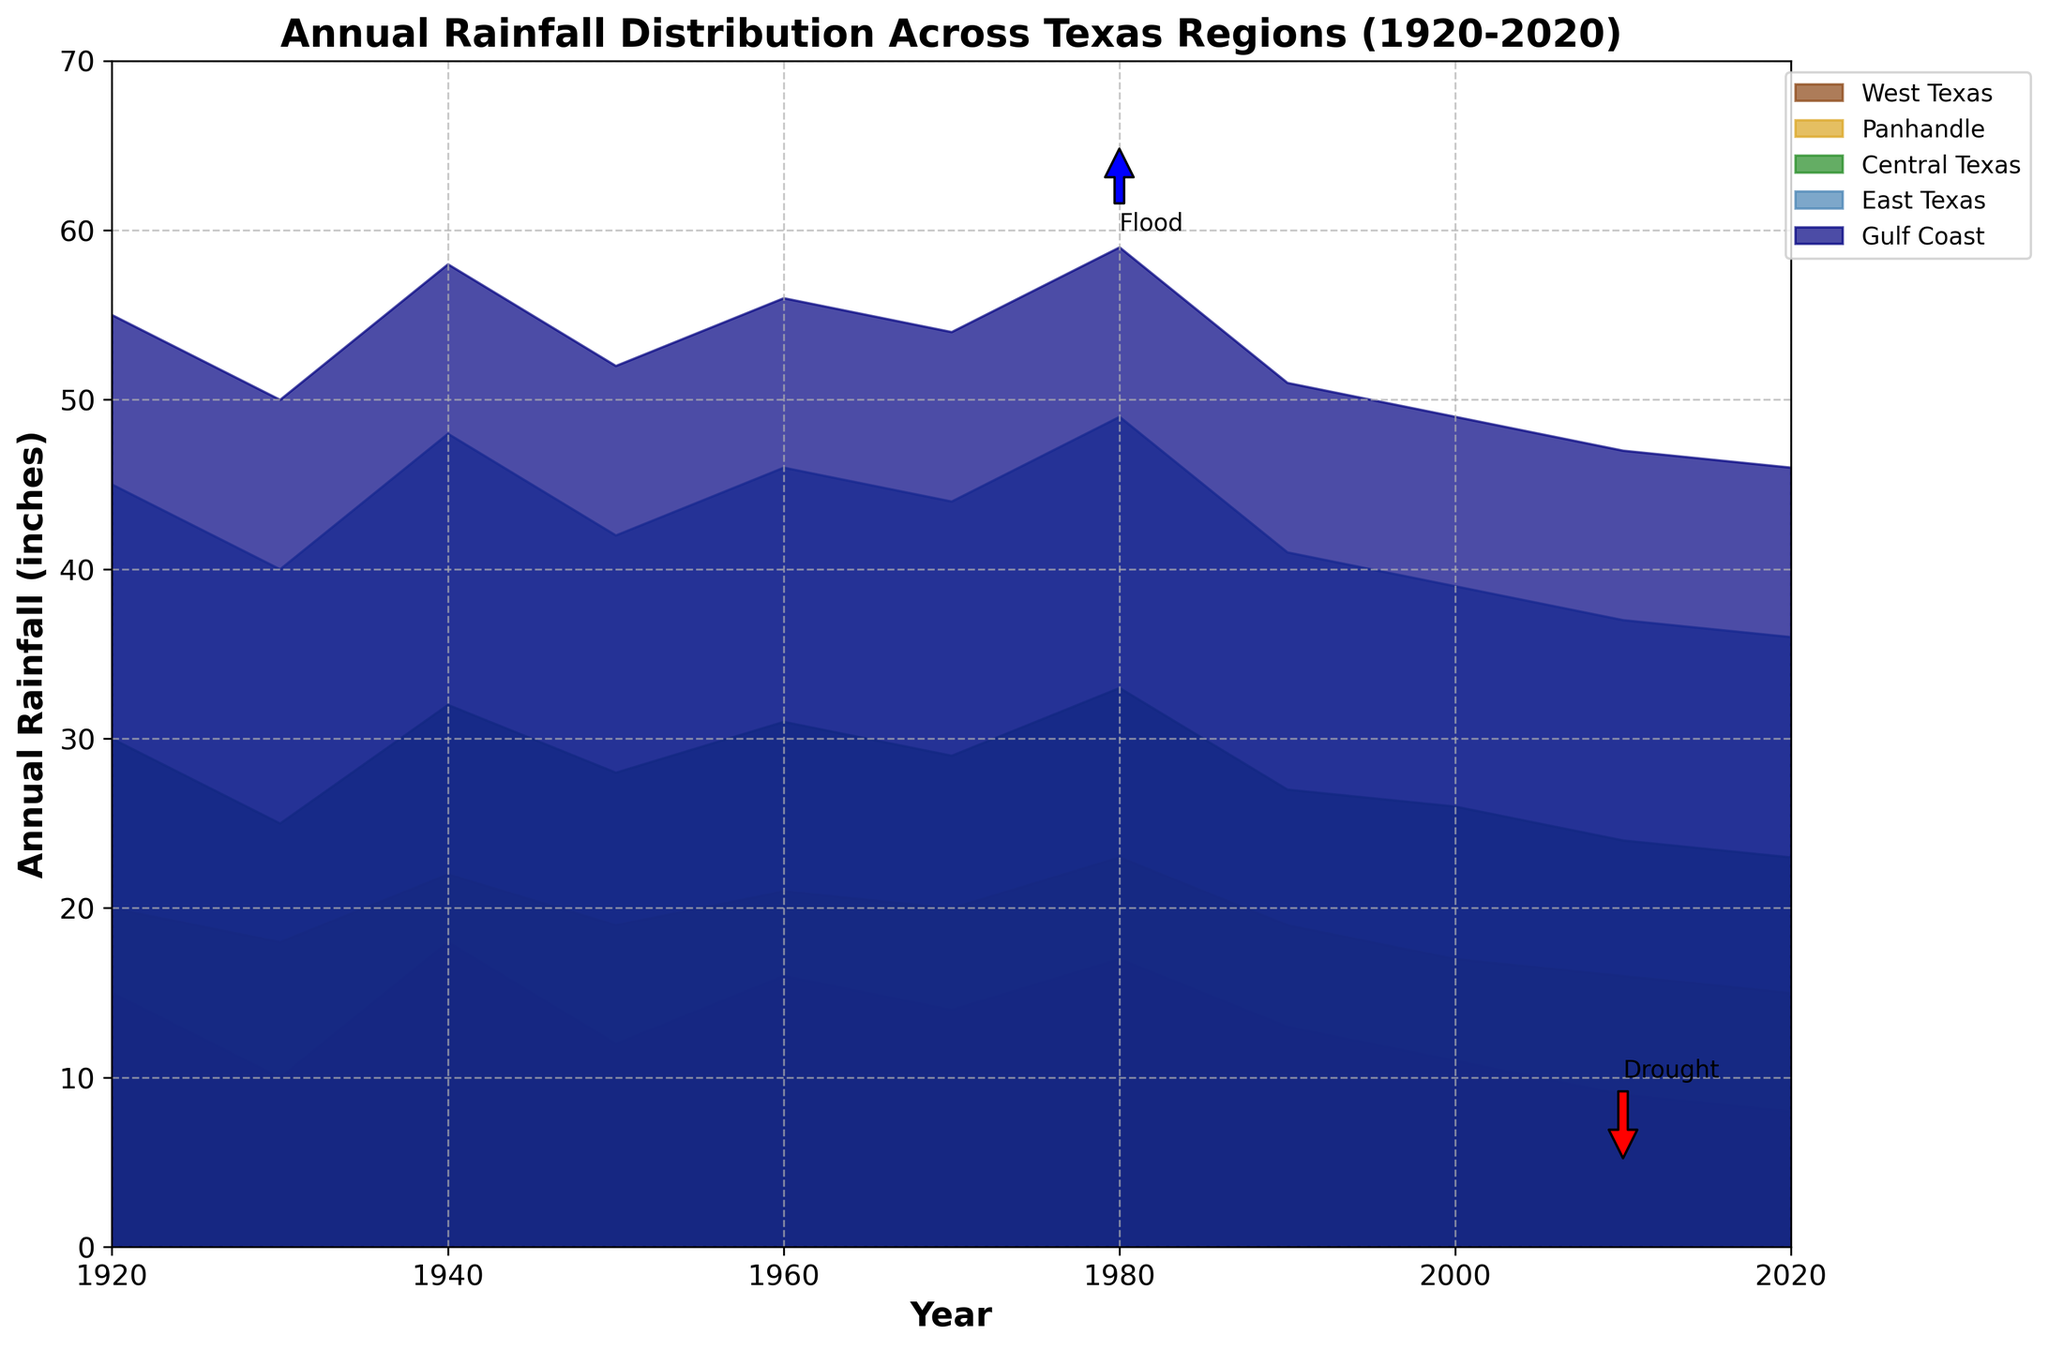What is the title of the chart? The title is typically found at the top of the chart and provides an overview of what the chart represents. It reads "Annual Rainfall Distribution Across Texas Regions (1920-2020)".
Answer: Annual Rainfall Distribution Across Texas Regions (1920-2020) Which Texas region had the highest rainfall in 1980? To find this, look at the highest point in the colored bands in 1980. The Gulf Coast region exhibits the highest rainfall, reaching almost 60 inches.
Answer: Gulf Coast What is the range of annual rainfall for West Texas over the century? For this, observe the range of the West Texas band from 1920 to 2020. It varies roughly from 8 to 18 inches.
Answer: 8 to 18 inches Which Texas region shows a consistent decline in rainfall from 1920 to 2020? To determine this, look for a consistent downward trend in the visual representation. West Texas shows a steady decline from 15 inches in 1920 to 8 inches in 2020.
Answer: West Texas Between the years 2000 and 2020, how does the rainfall in Central Texas compare to East Texas? Compare the bands for Central Texas and East Texas between these years. East Texas consistently shows higher rainfall compared to Central Texas in this period.
Answer: East Texas has more rainfall than Central Texas Which years are annotated as drought and flood in the chart? Look for annotations on the chart pointing out specific years. The drought is marked in 2010, and the flood is marked in 1980.
Answer: 2010 (drought) and 1980 (flood) In which year did East Texas receive the maximum rainfall? Find the peak point in the East Texas band. The highest rainfall for East Texas occurs in 1980.
Answer: 1980 During which year did the Panhandle region show the lowest rainfall, and what was the value? Look for the lowest point in the Panhandle band. In 2020, the Panhandle shows the lowest rainfall at about 15 inches.
Answer: 2020, 15 inches What is the total rainfall for the Gulf Coast from 1930 to 1950? Add the rainfall values from the Gulf Coast band for the years 1930, 1940, and 1950. The values are 50, 58, and 52 inches respectively. Summing these, we get 160 inches.
Answer: 160 inches How does the rainfall in 1970 for Central Texas compare to the rainfall in 1990 for the same region? Compare the height of the Central Texas band in 1970 to that in 1990. Central Texas had higher rainfall in 1970 (around 29 inches) compared to 1990 (around 27 inches).
Answer: Higher in 1970 